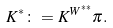<formula> <loc_0><loc_0><loc_500><loc_500>K ^ { * } \colon = K ^ { W ^ { * * } } \pi .</formula> 